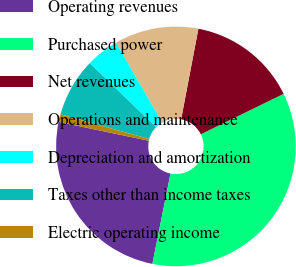Convert chart to OTSL. <chart><loc_0><loc_0><loc_500><loc_500><pie_chart><fcel>Operating revenues<fcel>Purchased power<fcel>Net revenues<fcel>Operations and maintenance<fcel>Depreciation and amortization<fcel>Taxes other than income taxes<fcel>Electric operating income<nl><fcel>25.13%<fcel>35.38%<fcel>14.77%<fcel>11.33%<fcel>4.46%<fcel>7.9%<fcel>1.03%<nl></chart> 